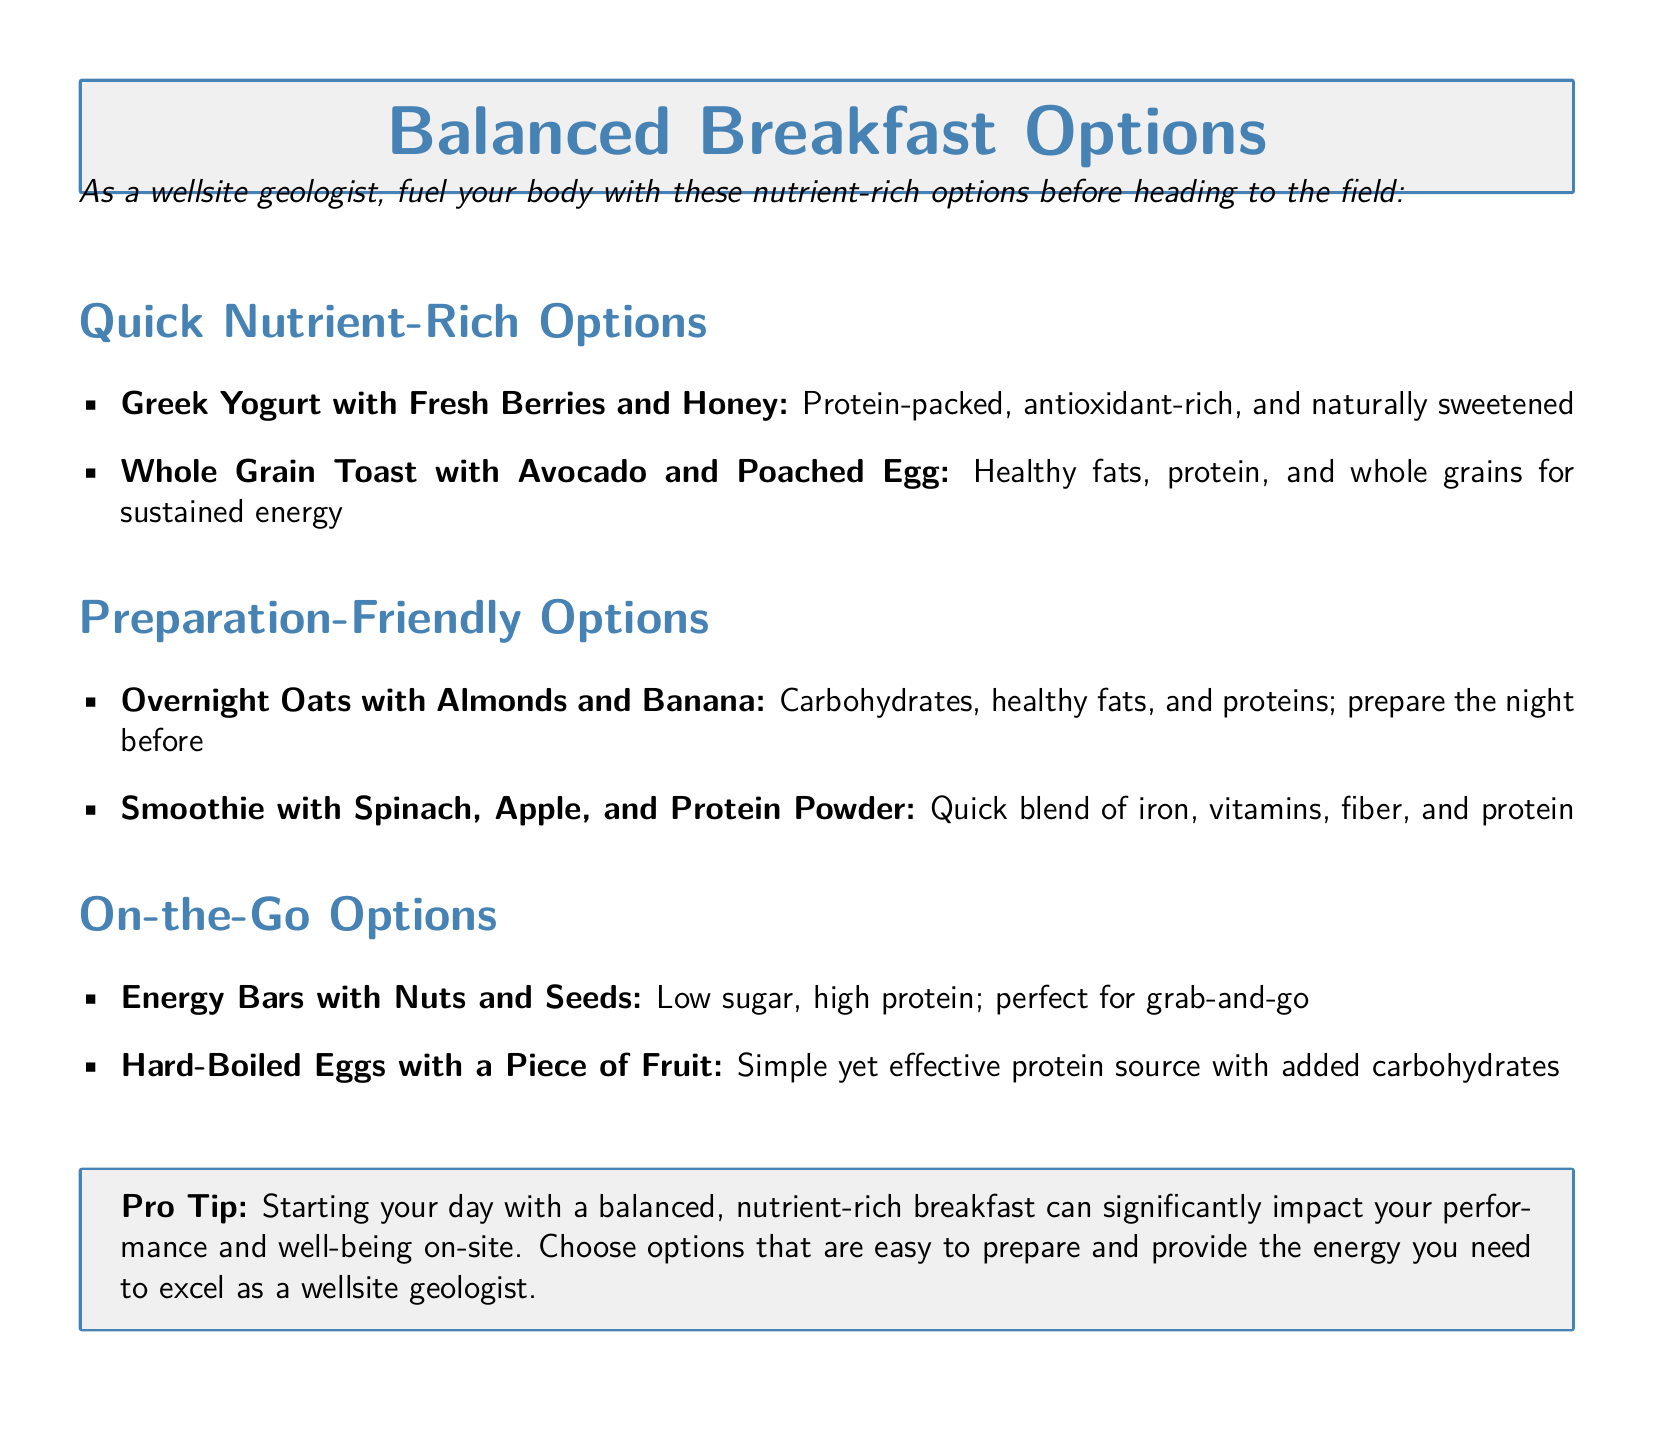What are two quick nutrient-rich breakfast options? The document lists Greek Yogurt with Fresh Berries and Honey and Whole Grain Toast with Avocado and Poached Egg as quick nutrient-rich options.
Answer: Greek Yogurt with Fresh Berries and Honey, Whole Grain Toast with Avocado and Poached Egg What is a good preparation-friendly breakfast option? The document mentions Overnight Oats with Almonds and Banana as a preparation-friendly option.
Answer: Overnight Oats with Almonds and Banana Which breakfast option is mentioned as an on-the-go choice? The document highlights Energy Bars with Nuts and Seeds as one of the on-the-go options.
Answer: Energy Bars with Nuts and Seeds How should breakfast be prepared for the Overnight Oats option? The document states that Overnight Oats with Almonds and Banana should be prepared the night before.
Answer: The night before What is the main benefit of starting the day with a balanced breakfast? The document notes that starting your day with a balanced breakfast can significantly impact your performance and well-being on-site.
Answer: Performance and well-being How many breakfast options are listed under Quick Nutrient-Rich Options? There are two options mentioned under the Quick Nutrient-Rich Options section.
Answer: Two 